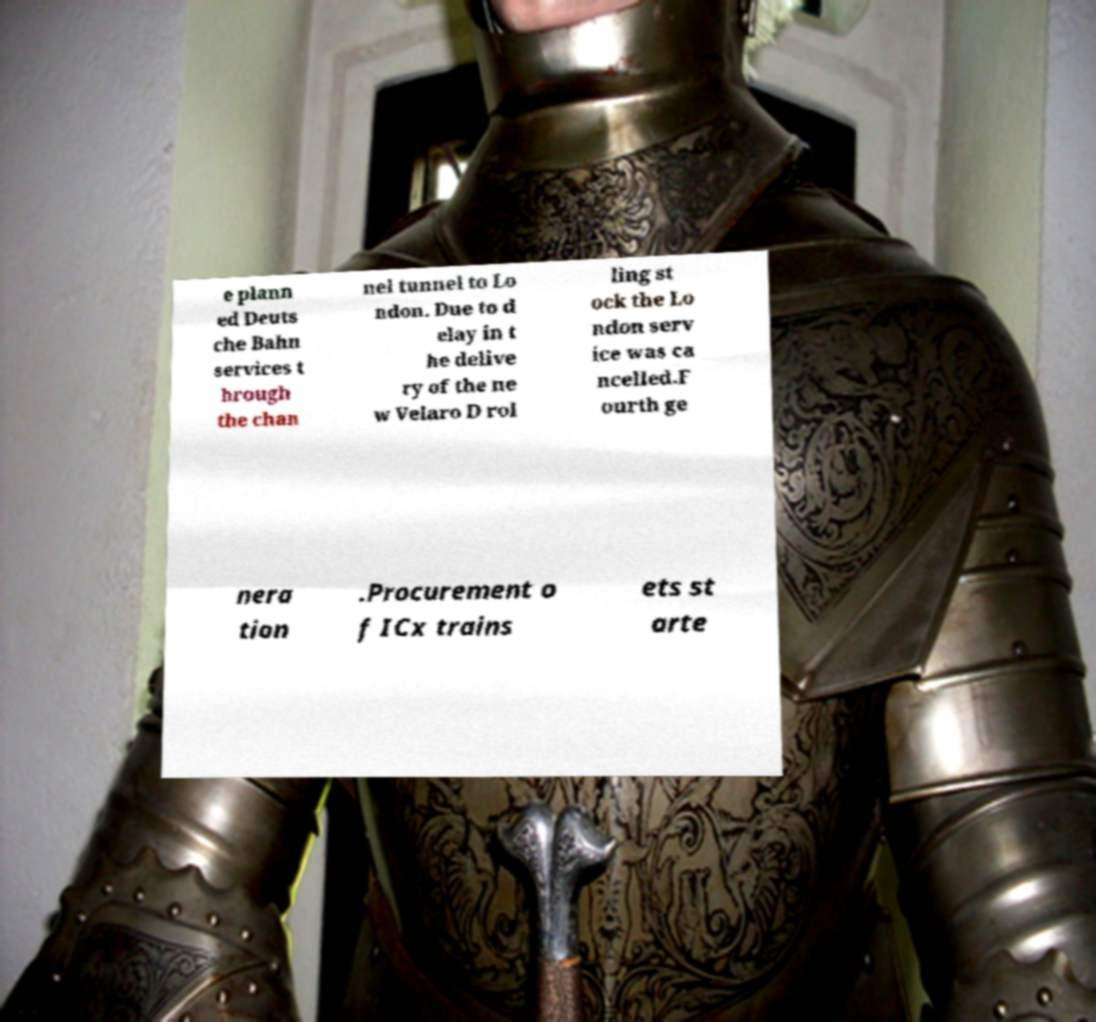Could you extract and type out the text from this image? e plann ed Deuts che Bahn services t hrough the chan nel tunnel to Lo ndon. Due to d elay in t he delive ry of the ne w Velaro D rol ling st ock the Lo ndon serv ice was ca ncelled.F ourth ge nera tion .Procurement o f ICx trains ets st arte 